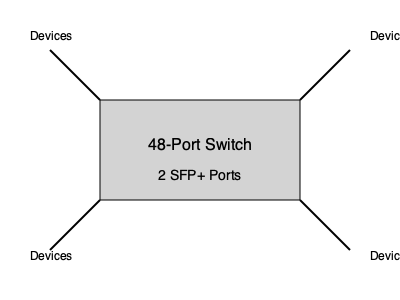A network switch has 48 Ethernet ports and 2 SFP+ ports. If one SFP+ port is used to connect to the core network, what is the maximum number of end devices that can be connected to this switch? To calculate the maximum number of devices that can be connected to the switch, we need to follow these steps:

1. Identify the total number of ports:
   - 48 Ethernet ports
   - 2 SFP+ ports
   Total ports = $48 + 2 = 50$

2. Consider the used ports:
   - 1 SFP+ port is used for core network connection

3. Calculate available ports for end devices:
   Available ports = Total ports - Used ports
   $50 - 1 = 49$

4. The maximum number of end devices that can be connected equals the number of available ports.

Therefore, the switch can accommodate a maximum of 49 end devices.

Note: In real-world scenarios, it's often recommended to leave some ports free for future expansion or troubleshooting. However, for this calculation, we're considering the absolute maximum theoretical capacity.
Answer: 49 devices 